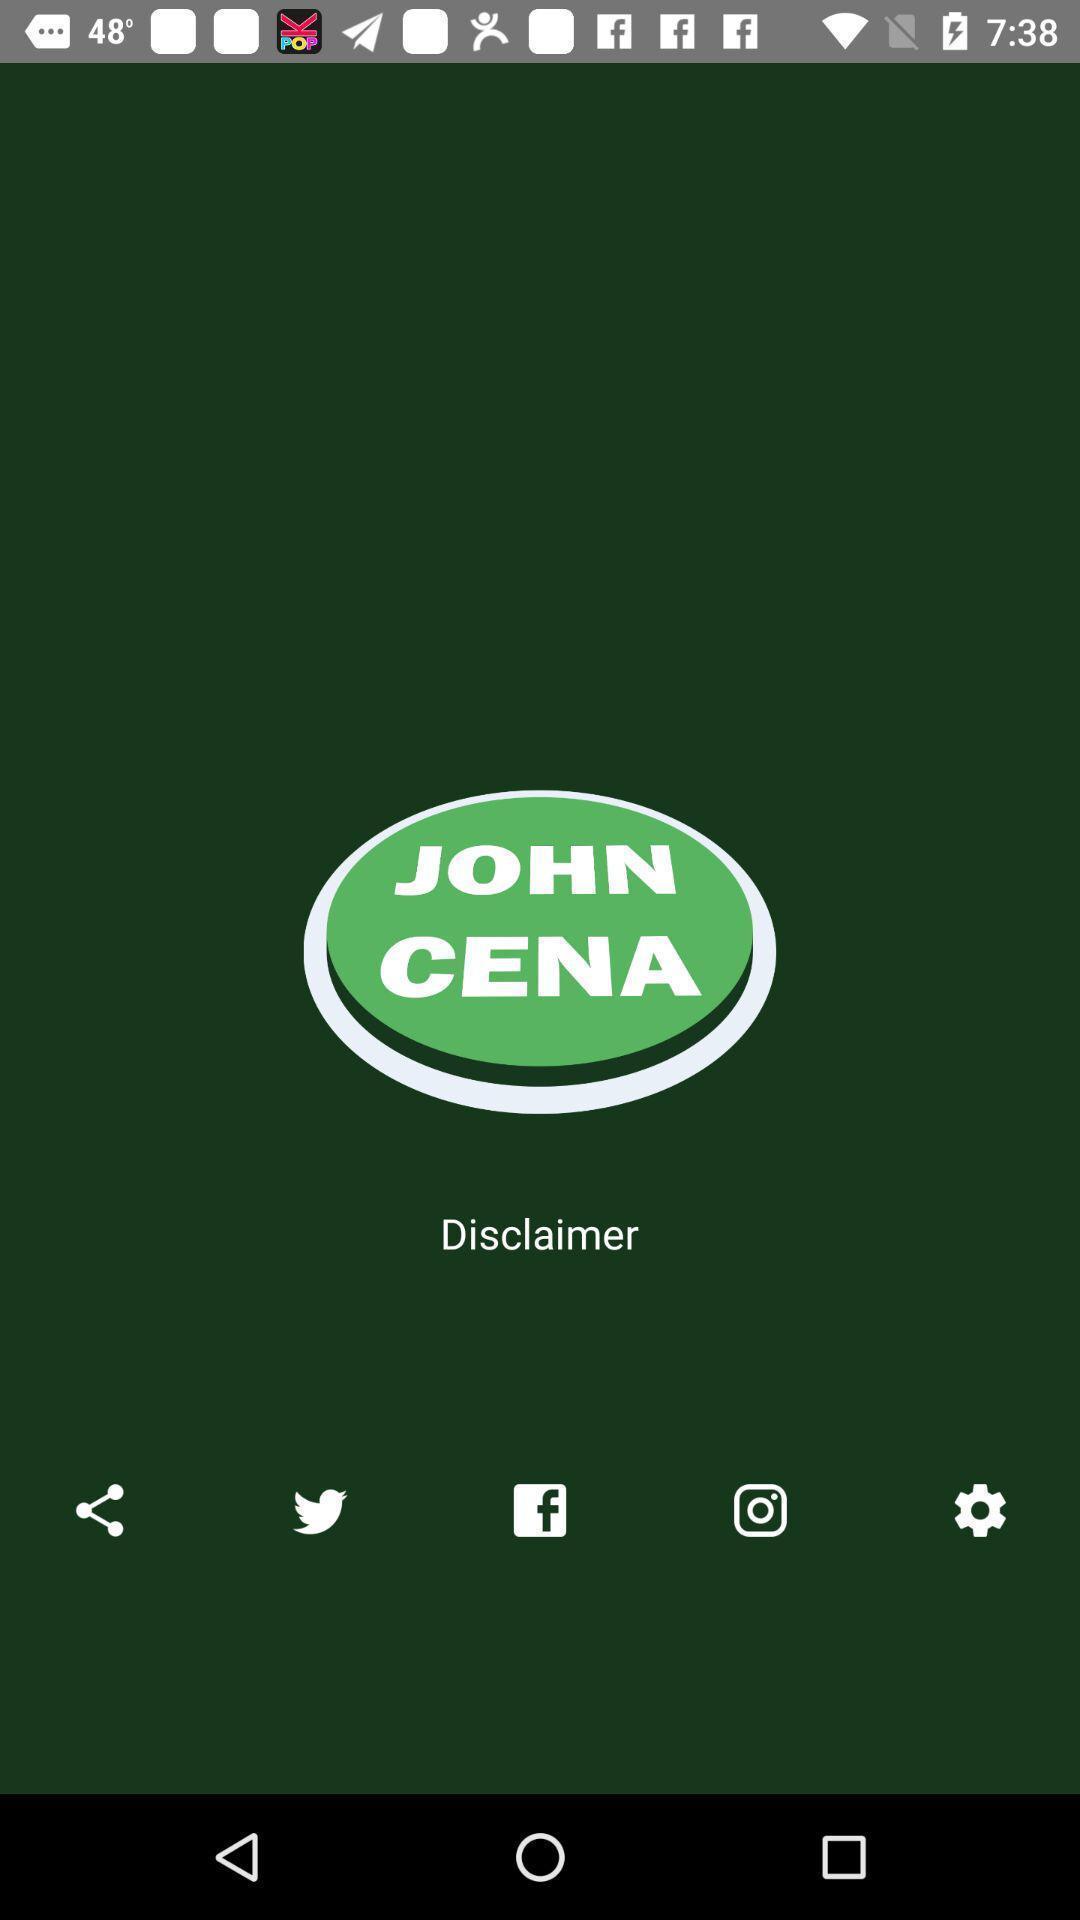Provide a description of this screenshot. Welcome page. 